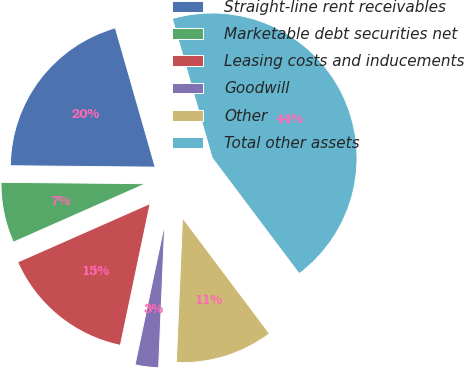Convert chart to OTSL. <chart><loc_0><loc_0><loc_500><loc_500><pie_chart><fcel>Straight-line rent receivables<fcel>Marketable debt securities net<fcel>Leasing costs and inducements<fcel>Goodwill<fcel>Other<fcel>Total other assets<nl><fcel>20.41%<fcel>6.77%<fcel>15.09%<fcel>2.62%<fcel>10.93%<fcel>44.19%<nl></chart> 